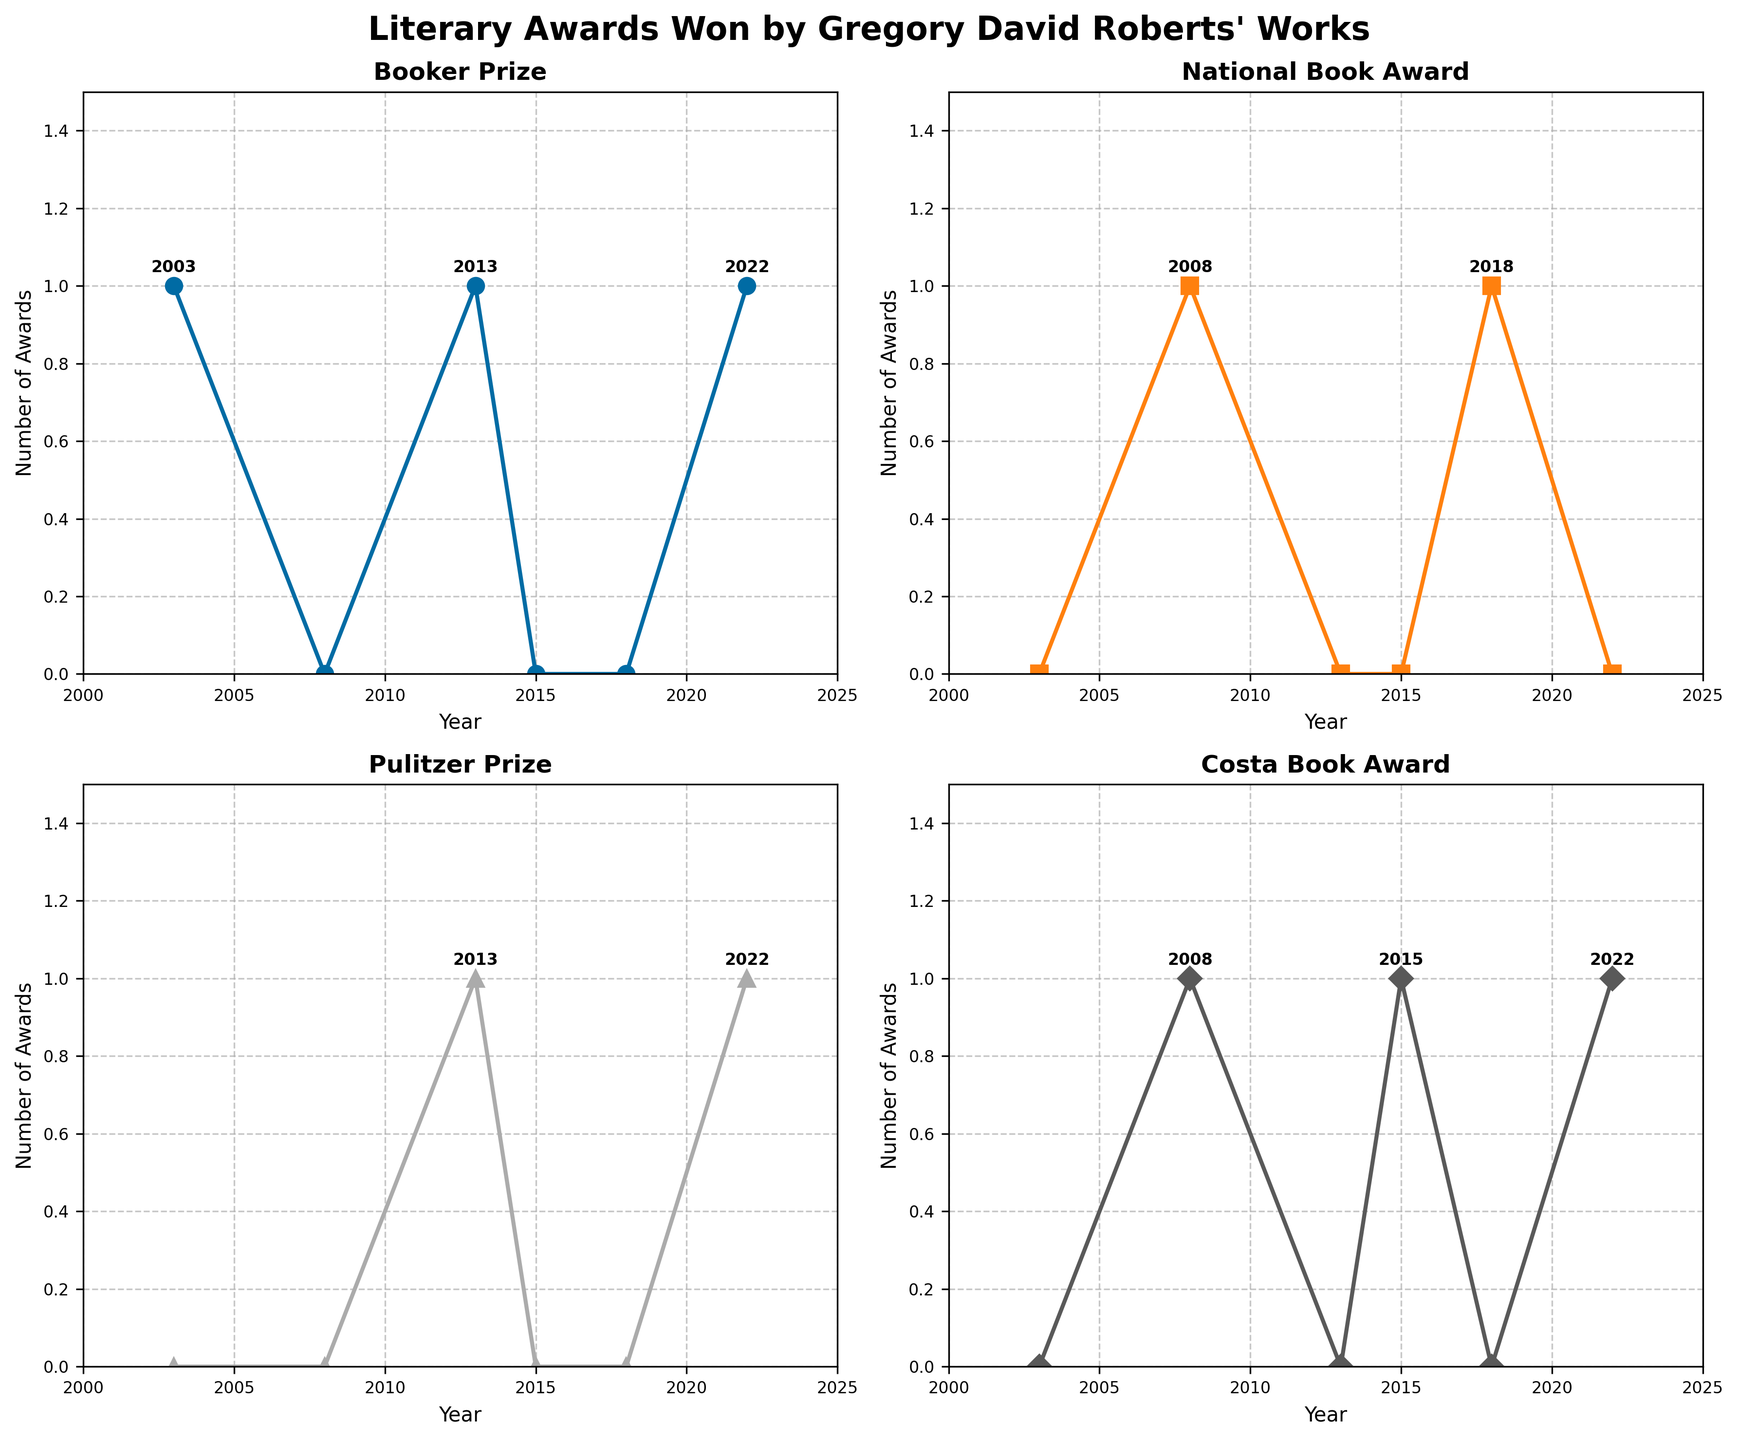What's the title of the figure? The title is displayed at the top center of the figure. It reads, "Literary Awards Won by Gregory David Roberts' Works."
Answer: Literary Awards Won by Gregory David Roberts' Works How many awards did Gregory David Roberts win in 2013? In 2013, awards are indicated by points on the vertical axis corresponding to the year 2013. There is 1 Booker Prize and 1 Pulitzer Prize, making a total of 2 awards.
Answer: 2 Which award has the highest number of data points marked? By checking each subplot, it is evident that all awards have data points marked in 4 different years.
Answer: All awards have equal data points Did Gregory David Roberts win the Booker Prize in 2008? The Booker Prize subplot for 2008 shows no points, indicating he did not win the Booker Prize that year.
Answer: No In which years did Gregory David Roberts win the Costa Book Award? Observing the Costa Book Award subplot, points indicating awards occur in the years 2008, 2015, and 2022.
Answer: 2008, 2015, 2022 Compare the number of Pulitzer Prizes won in 2013 and 2022. In the Pulitzer Prize subplot, a point is marked for both 2013 and 2022, indicating 1 award for each year.
Answer: Equal How many times did Gregory David Roberts win the National Book Award from 2003 to 2022? Viewing the National Book Award subplot, awards are marked for the years 2008 and 2018, indicating he won it 2 times.
Answer: 2 What is the color used for the line representing the Booker Prize? In the Booker Prize subplot and legend, the line color is a shade of blue.
Answer: Blue Which year recorded the highest number of different awards won? By examining the subplots for each award and counting the unique years they won, 2022 stands out with 3 different awards (Booker Prize, Pulitzer Prize, Costa Book Award).
Answer: 2022 